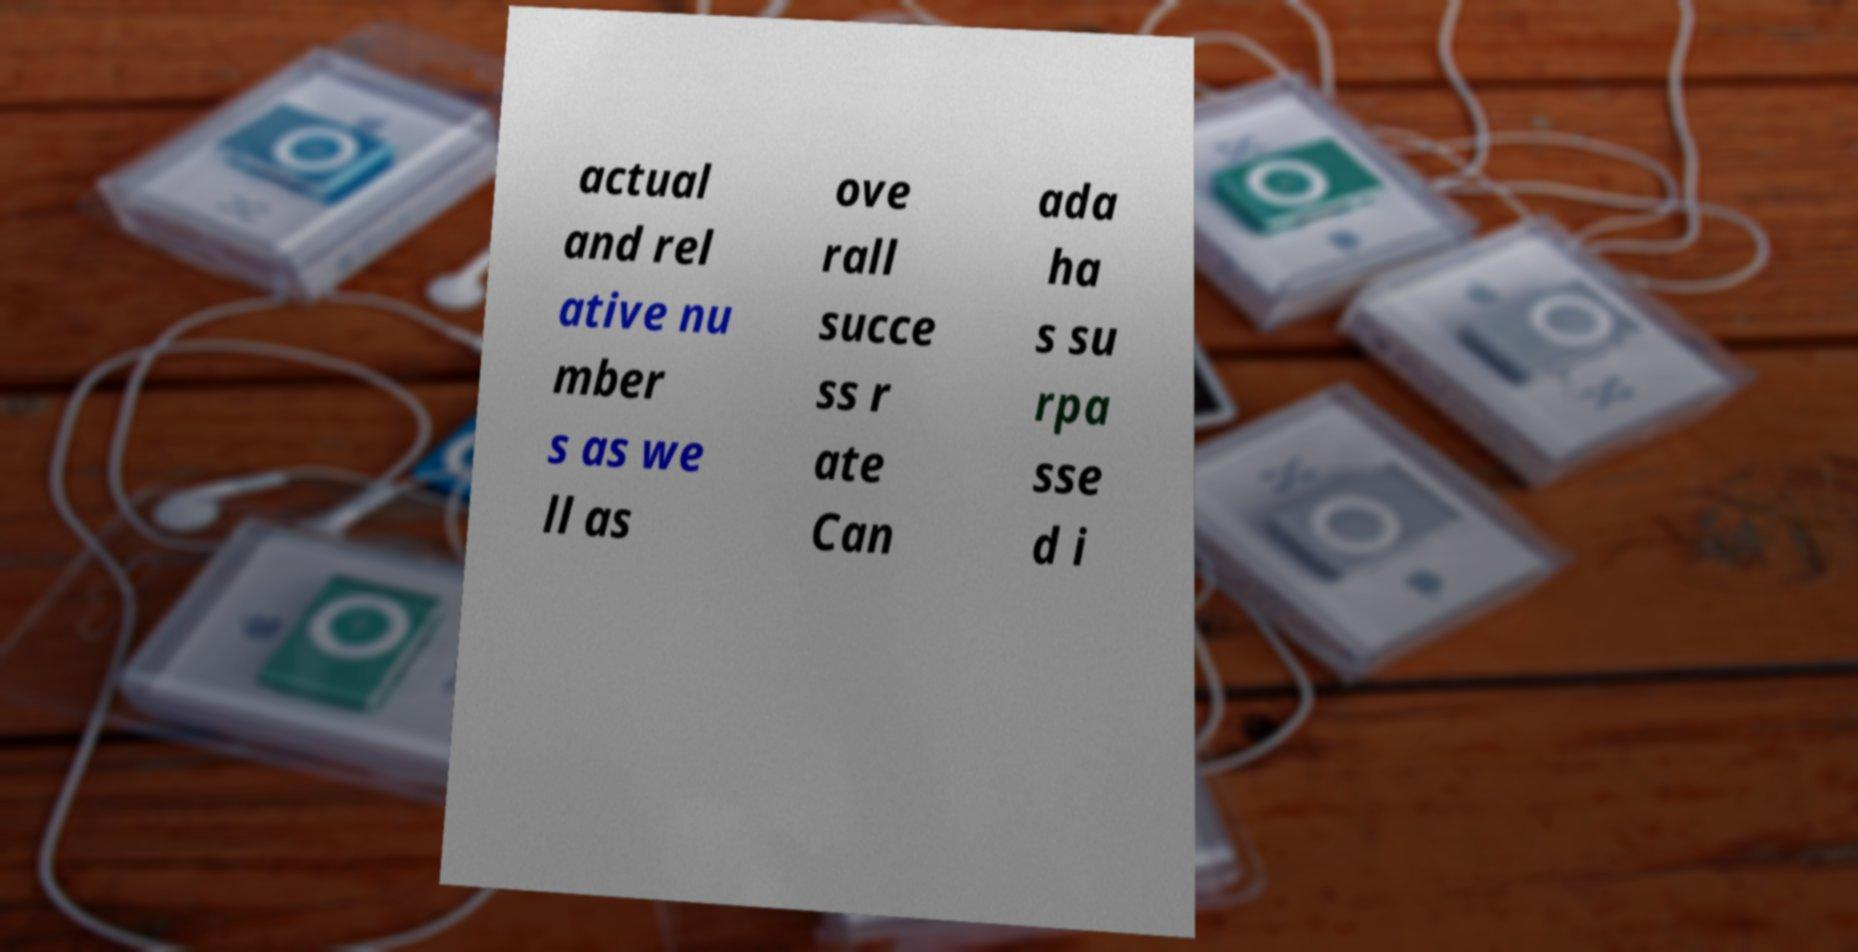Can you accurately transcribe the text from the provided image for me? actual and rel ative nu mber s as we ll as ove rall succe ss r ate Can ada ha s su rpa sse d i 